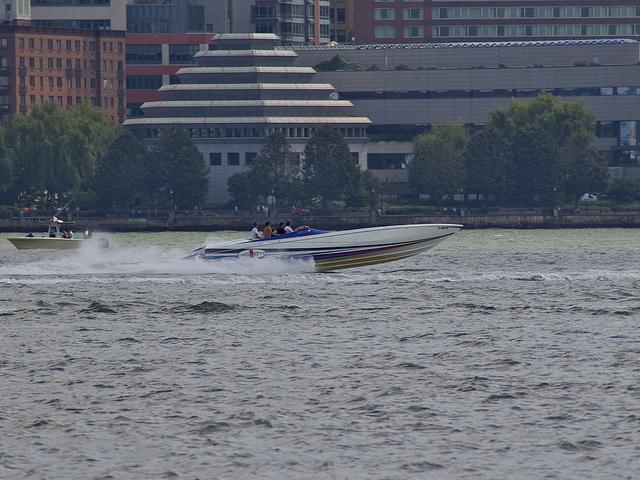How many people are on the boat?
Give a very brief answer. 4. 